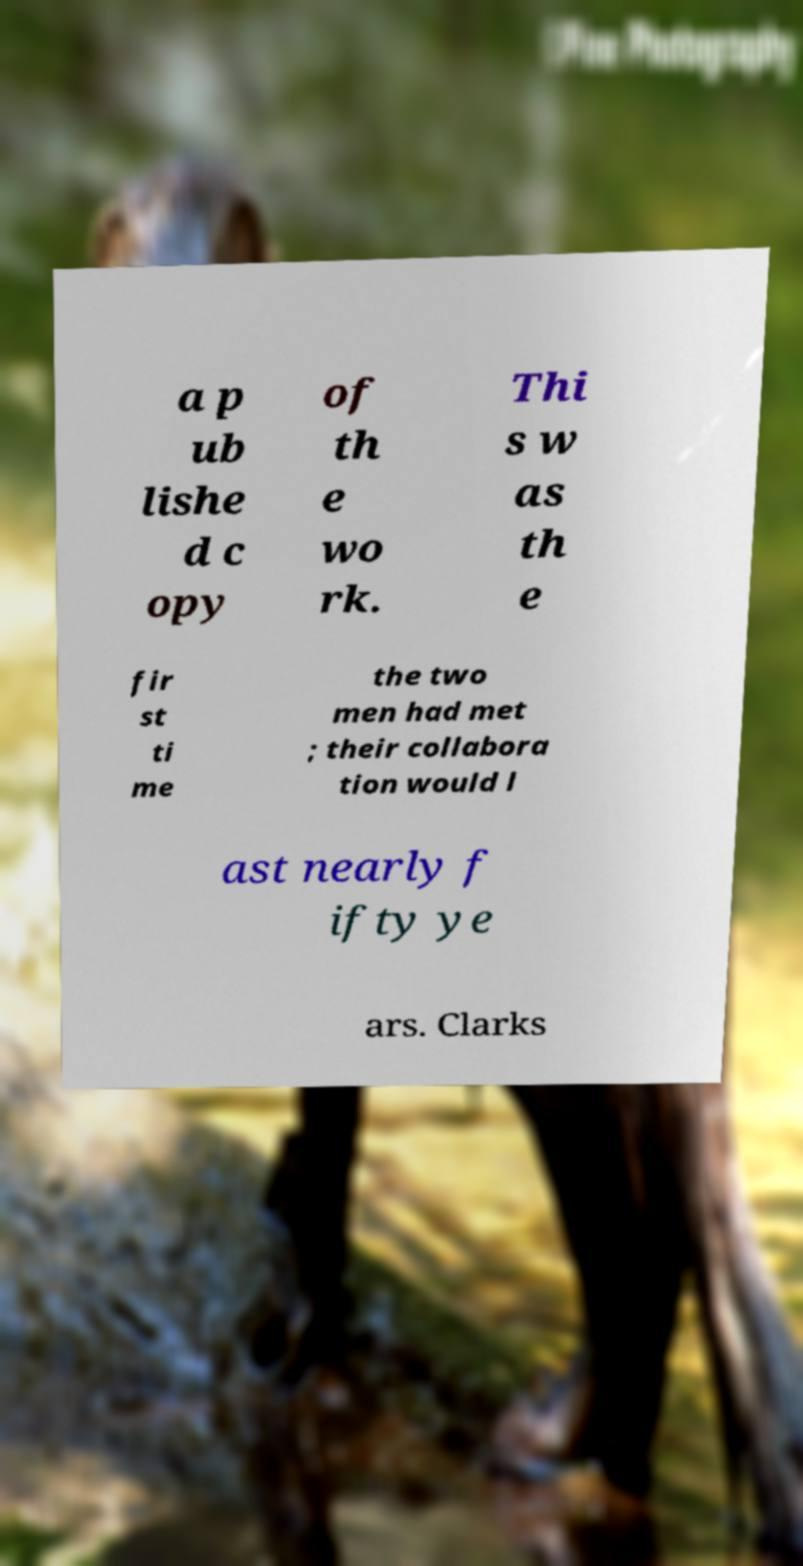What messages or text are displayed in this image? I need them in a readable, typed format. a p ub lishe d c opy of th e wo rk. Thi s w as th e fir st ti me the two men had met ; their collabora tion would l ast nearly f ifty ye ars. Clarks 